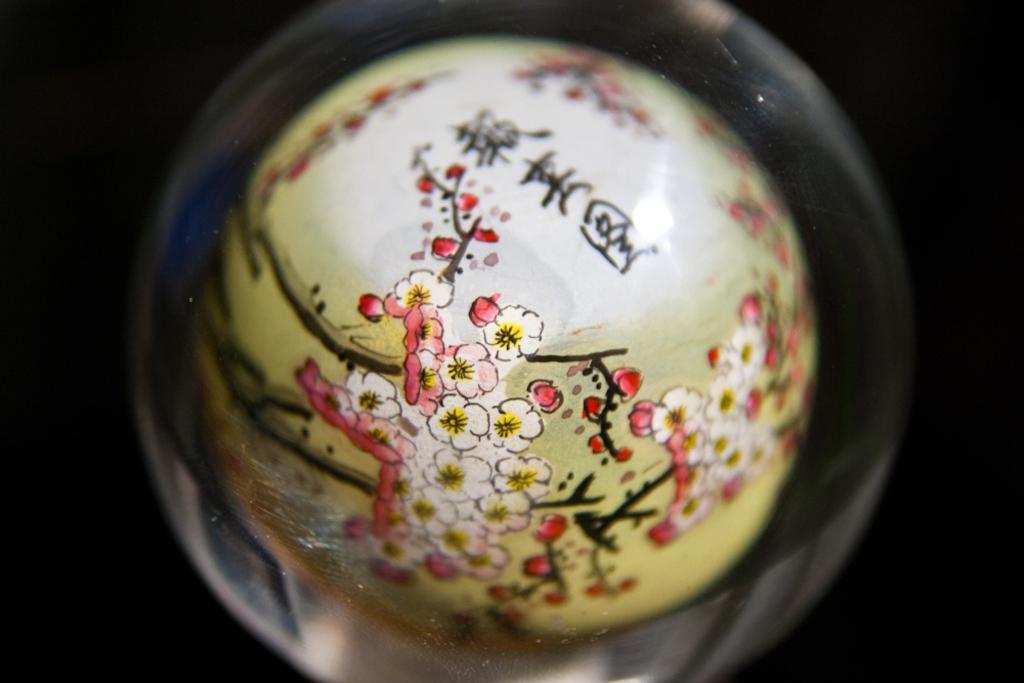Please provide a concise description of this image. In this picture there is a ceramic in the center of the image. 